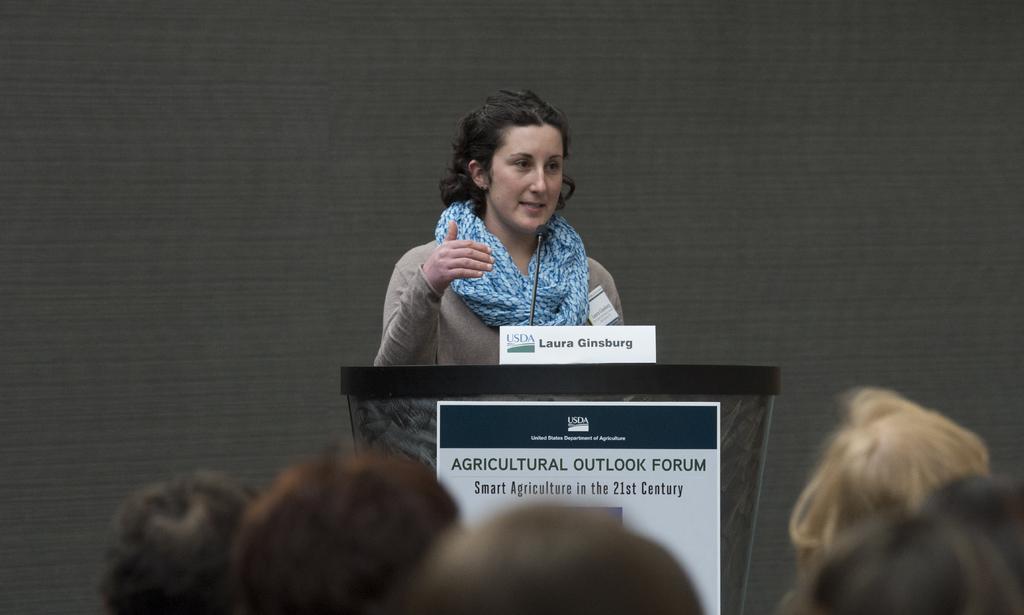Please provide a concise description of this image. In this image I can see a woman is standing in front of a podium. The woman is wearing a blue color scarf and a T-shirt. On the podium I can see a board on which something written on it and microphone. Here I can see some people. 